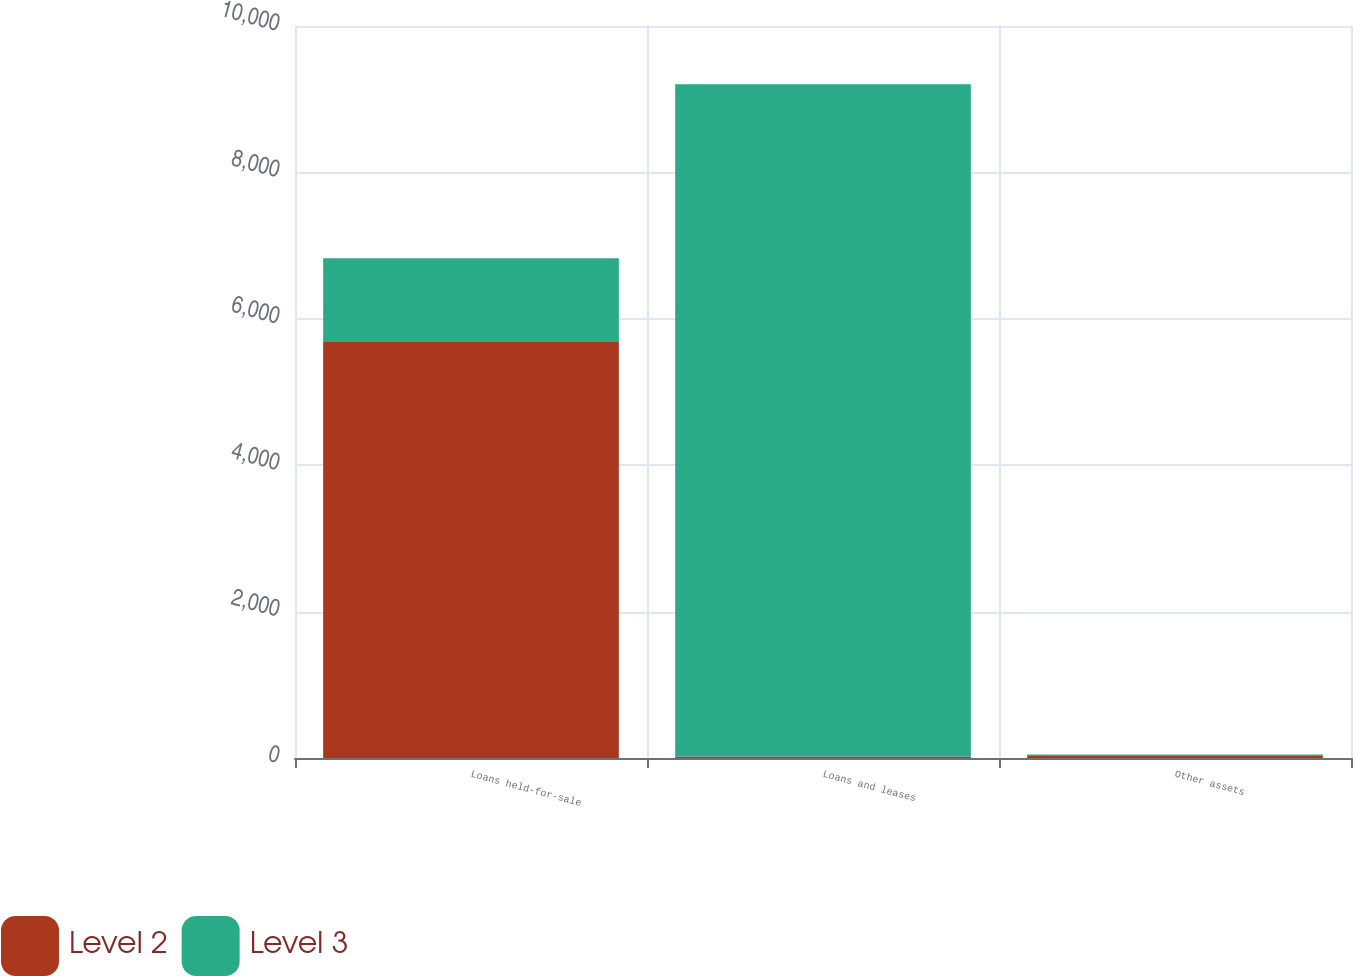<chart> <loc_0><loc_0><loc_500><loc_500><stacked_bar_chart><ecel><fcel>Loans held-for-sale<fcel>Loans and leases<fcel>Other assets<nl><fcel>Level 2<fcel>5692<fcel>21<fcel>36<nl><fcel>Level 3<fcel>1136<fcel>9184<fcel>12<nl></chart> 